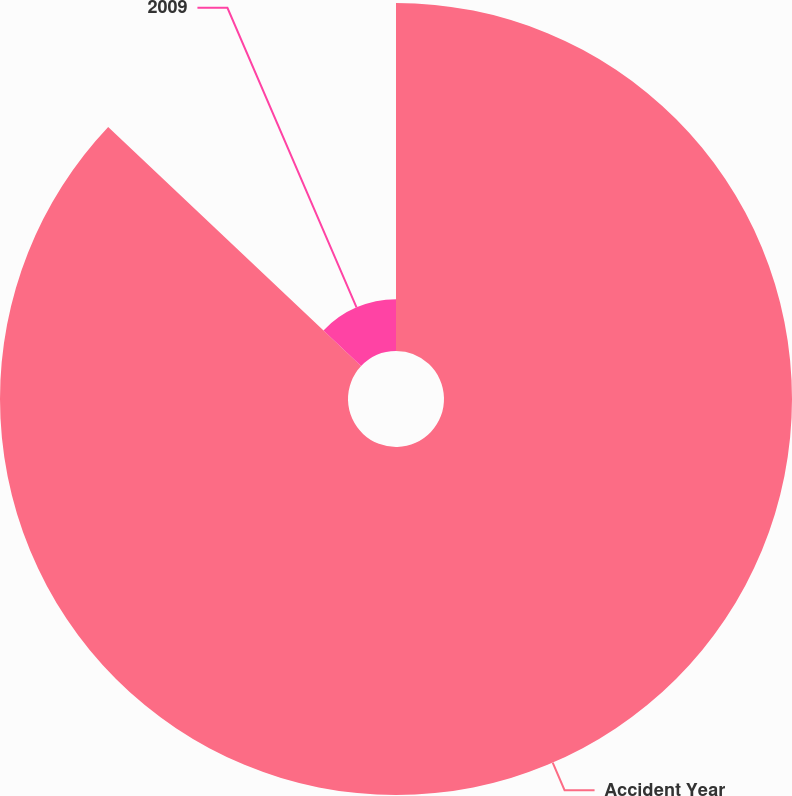Convert chart. <chart><loc_0><loc_0><loc_500><loc_500><pie_chart><fcel>Accident Year<fcel>2009<nl><fcel>87.05%<fcel>12.95%<nl></chart> 